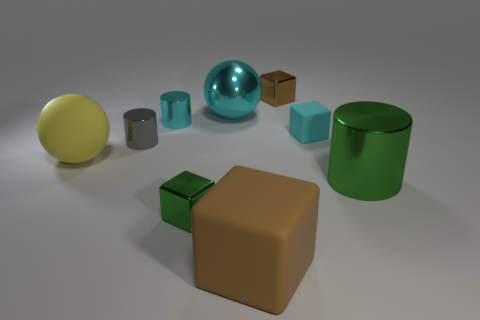What is the size of the rubber object left of the brown thing in front of the small cyan object that is behind the cyan rubber object?
Provide a short and direct response. Large. What material is the gray object?
Give a very brief answer. Metal. There is a metallic ball that is the same color as the tiny rubber object; what is its size?
Keep it short and to the point. Large. There is a yellow object; is its shape the same as the green metal object to the left of the cyan matte thing?
Offer a terse response. No. What is the material of the big ball in front of the matte thing right of the metal block right of the big brown cube?
Provide a short and direct response. Rubber. What number of yellow metallic balls are there?
Ensure brevity in your answer.  0. What number of cyan objects are either small rubber objects or large blocks?
Ensure brevity in your answer.  1. What number of other things are there of the same shape as the gray object?
Keep it short and to the point. 2. Is the color of the big rubber cube that is in front of the yellow matte thing the same as the tiny metal cube behind the small gray cylinder?
Your answer should be compact. Yes. How many large objects are cyan cylinders or cyan shiny objects?
Your answer should be very brief. 1. 